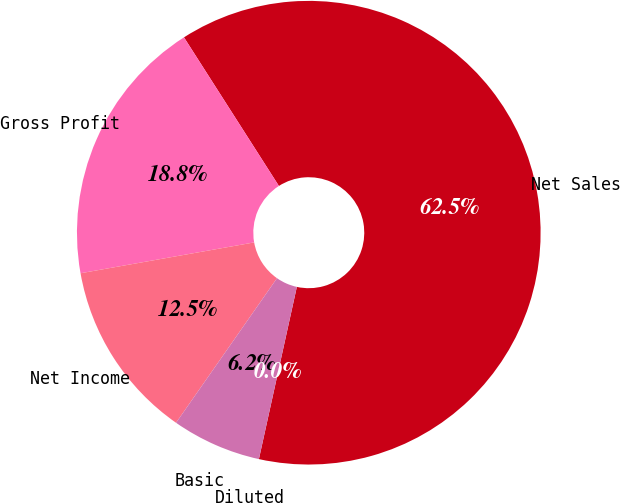<chart> <loc_0><loc_0><loc_500><loc_500><pie_chart><fcel>Net Sales<fcel>Gross Profit<fcel>Net Income<fcel>Basic<fcel>Diluted<nl><fcel>62.5%<fcel>18.75%<fcel>12.5%<fcel>6.25%<fcel>0.0%<nl></chart> 